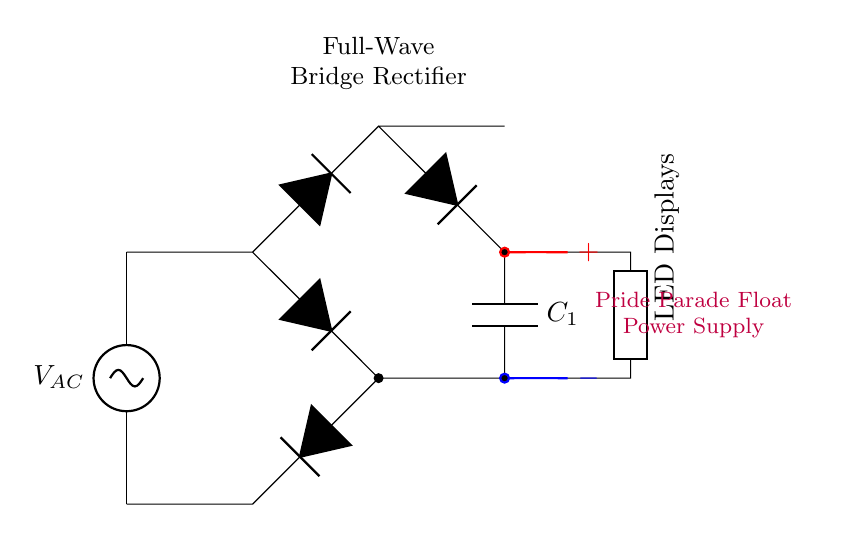What type of rectifier is depicted? The circuit diagram shows a full-wave bridge rectifier, identified by the arrangement of four diodes arranged in a bridge configuration.
Answer: full-wave bridge rectifier What does C1 do in the circuit? The capacitor labeled C1 smooths out the voltage fluctuations after rectification, providing a more stable voltage to the LED displays.
Answer: smooths voltage How many diodes are used in this circuit? There are four diodes used in the bridge rectifier configuration, which is essential for full-wave rectification of the AC voltage.
Answer: four What is the output connection of the rectifier? The output connections are the points where the LED displays connect, marked with positive and negative terminals, indicating the direct current output.
Answer: positive and negative terminals What type of load does this circuit power? The load in this circuit is LED displays, as indicated by the labeling next to the connection.
Answer: LED displays Why is smoothing necessary for the LED displays? Smoothing is necessary to prevent flickering and to provide a constant current to the LED displays, which ensures consistent brightness and performance during operation.
Answer: to prevent flickering 